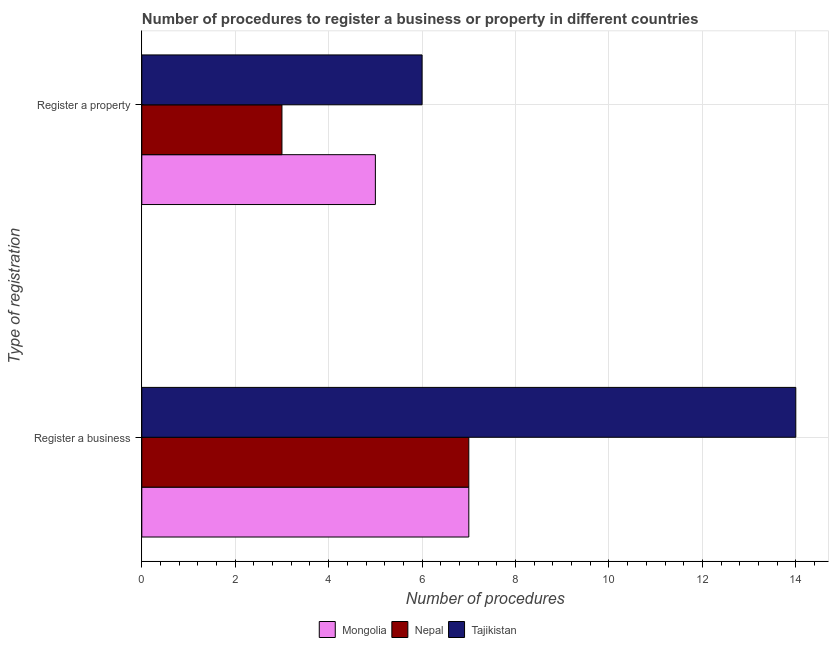How many bars are there on the 1st tick from the bottom?
Give a very brief answer. 3. What is the label of the 1st group of bars from the top?
Keep it short and to the point. Register a property. Across all countries, what is the minimum number of procedures to register a property?
Keep it short and to the point. 3. In which country was the number of procedures to register a business maximum?
Offer a terse response. Tajikistan. In which country was the number of procedures to register a business minimum?
Your response must be concise. Mongolia. What is the total number of procedures to register a property in the graph?
Offer a terse response. 14. What is the difference between the number of procedures to register a property in Tajikistan and that in Mongolia?
Offer a terse response. 1. What is the difference between the number of procedures to register a property in Nepal and the number of procedures to register a business in Mongolia?
Ensure brevity in your answer.  -4. What is the average number of procedures to register a property per country?
Ensure brevity in your answer.  4.67. What is the difference between the number of procedures to register a property and number of procedures to register a business in Tajikistan?
Make the answer very short. -8. In how many countries, is the number of procedures to register a property greater than 8.8 ?
Offer a very short reply. 0. What is the ratio of the number of procedures to register a business in Tajikistan to that in Nepal?
Your answer should be very brief. 2. In how many countries, is the number of procedures to register a business greater than the average number of procedures to register a business taken over all countries?
Offer a terse response. 1. What does the 1st bar from the top in Register a business represents?
Ensure brevity in your answer.  Tajikistan. What does the 1st bar from the bottom in Register a property represents?
Your response must be concise. Mongolia. Are all the bars in the graph horizontal?
Make the answer very short. Yes. Where does the legend appear in the graph?
Give a very brief answer. Bottom center. How many legend labels are there?
Keep it short and to the point. 3. What is the title of the graph?
Offer a terse response. Number of procedures to register a business or property in different countries. What is the label or title of the X-axis?
Provide a short and direct response. Number of procedures. What is the label or title of the Y-axis?
Provide a succinct answer. Type of registration. What is the Number of procedures of Nepal in Register a business?
Offer a very short reply. 7. Across all Type of registration, what is the maximum Number of procedures in Mongolia?
Provide a short and direct response. 7. Across all Type of registration, what is the maximum Number of procedures in Tajikistan?
Keep it short and to the point. 14. Across all Type of registration, what is the minimum Number of procedures of Mongolia?
Keep it short and to the point. 5. Across all Type of registration, what is the minimum Number of procedures in Nepal?
Make the answer very short. 3. What is the total Number of procedures of Mongolia in the graph?
Give a very brief answer. 12. What is the total Number of procedures of Tajikistan in the graph?
Provide a short and direct response. 20. What is the difference between the Number of procedures of Mongolia in Register a business and that in Register a property?
Your answer should be compact. 2. What is the difference between the Number of procedures of Mongolia in Register a business and the Number of procedures of Tajikistan in Register a property?
Your response must be concise. 1. What is the difference between the Number of procedures of Nepal in Register a business and the Number of procedures of Tajikistan in Register a property?
Make the answer very short. 1. What is the average Number of procedures of Mongolia per Type of registration?
Provide a short and direct response. 6. What is the average Number of procedures of Nepal per Type of registration?
Your answer should be compact. 5. What is the average Number of procedures in Tajikistan per Type of registration?
Your answer should be very brief. 10. What is the difference between the Number of procedures in Mongolia and Number of procedures in Nepal in Register a business?
Give a very brief answer. 0. What is the difference between the Number of procedures in Nepal and Number of procedures in Tajikistan in Register a business?
Provide a short and direct response. -7. What is the difference between the Number of procedures in Mongolia and Number of procedures in Tajikistan in Register a property?
Offer a very short reply. -1. What is the ratio of the Number of procedures of Nepal in Register a business to that in Register a property?
Provide a short and direct response. 2.33. What is the ratio of the Number of procedures in Tajikistan in Register a business to that in Register a property?
Make the answer very short. 2.33. What is the difference between the highest and the second highest Number of procedures of Nepal?
Ensure brevity in your answer.  4. What is the difference between the highest and the lowest Number of procedures of Mongolia?
Make the answer very short. 2. What is the difference between the highest and the lowest Number of procedures in Tajikistan?
Offer a very short reply. 8. 